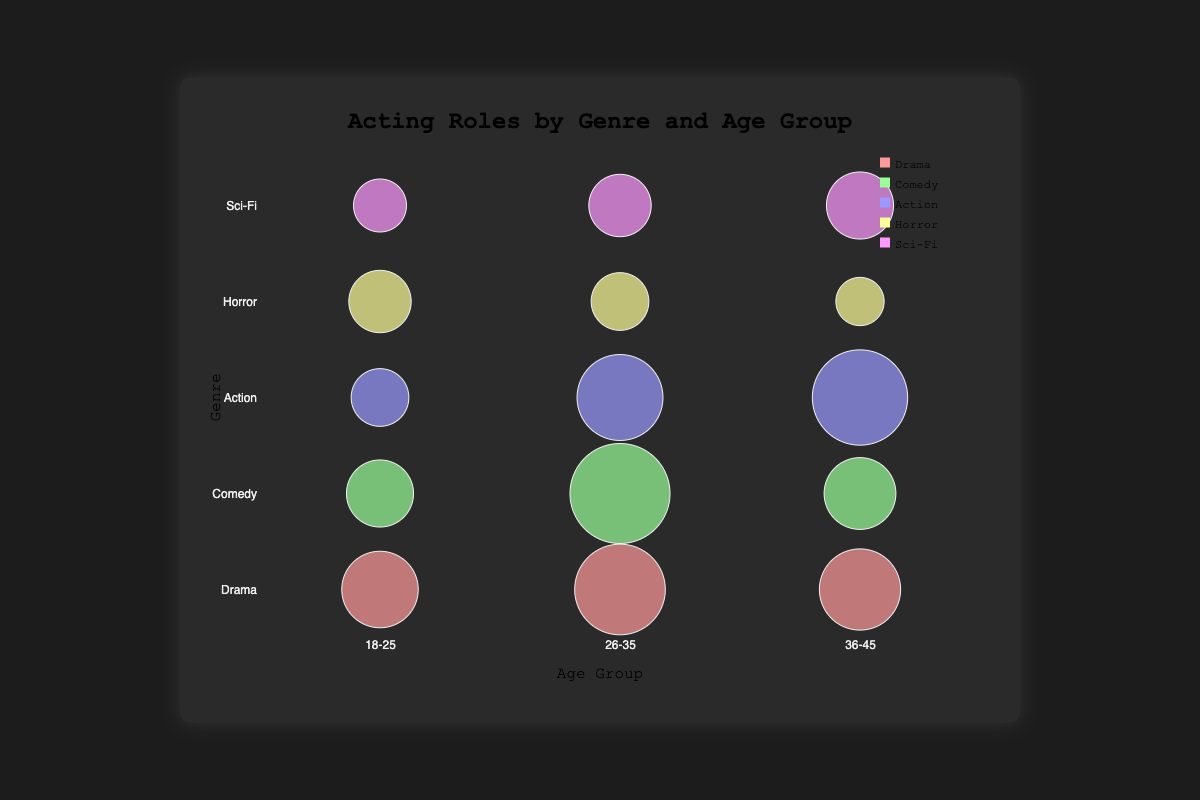What's the title of the bubble chart? The title is displayed at the top center of the chart. It reads "Acting Roles by Genre and Age Group."
Answer: Acting Roles by Genre and Age Group Which genre has the largest bubble for actors aged 26-35? The size of the bubbles represents the number of acting roles. The Comedy genre has the largest bubble for the 26-35 age group, indicating 170 roles, played by Ryan Reynolds.
Answer: Comedy Which actor has the largest number of roles in the Action genre? In the Action genre, we compare the bubble sizes across different age groups. The largest bubble belongs to the 36-45 age group actor, Dwayne Johnson, with 160 roles.
Answer: Dwayne Johnson How many roles does Zendaya have in the Comedy genre? By locating the Comedy genre and finding the bubble representing the 18-25 age group, the number of roles indicated by the bubble is 100.
Answer: 100 Compare the number of acting roles in Sci-Fi for the 18-25 age group to the 36-45 age group. Which age group has more roles and by how much? Locate the Sci-Fi genre and compare the bubble sizes for the two age groups. For 18-25, it is 70 roles (Millie Bobby Brown), and for 36-45, it is 100 roles (Oscar Isaac). The difference is 100 - 70 = 30 roles.
Answer: 36-45 by 30 roles What is the sum of roles in the Horror genre? Add up the number of roles for each age group in the Horror genre. 90 (18-25) + 80 (26-35) + 60 (36-45) = 230 roles.
Answer: 230 Which genre has the smallest number of roles in the 26-35 age group? Compare the bubble sizes for the 26-35 age group in each genre. The smallest bubble is in the Horror genre with 80 roles (Bill Skarsgård).
Answer: Horror What's the average number of acting roles in the Drama genre? To find the average, sum the roles for all age groups in Drama and divide by the number of age groups. (120 + 150 + 130) / 3 = 133.33 roles.
Answer: 133.33 Identify a genre where there is no actor with more than 100 roles in any age group. Examine the bubble sizes across different genres. In the Horror genre, no age group bubble exceeds 100 roles.
Answer: Horror Who is the actor with the most acting roles in the Drama genre, and how many roles do they have? Examine the Drama genre bubbles and identify the largest one, which corresponds to the 26-35 age group. Adam Driver is indicated with 150 roles.
Answer: Adam Driver, 150 